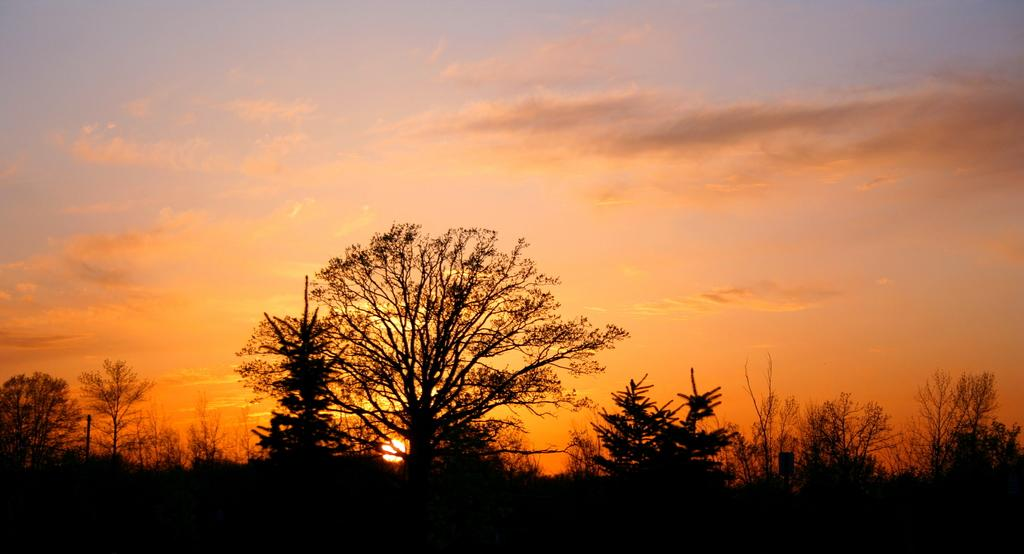What can be seen at the top of the image? The sky is visible in the image. What is present at the bottom of the image? There are trees and plants at the bottom of the image. Can you describe the celestial body visible in the image? The sun is visible in the image. How many deer can be seen grazing in the image? There are no deer present in the image. What time does the clock show in the image? There is no clock present in the image. 